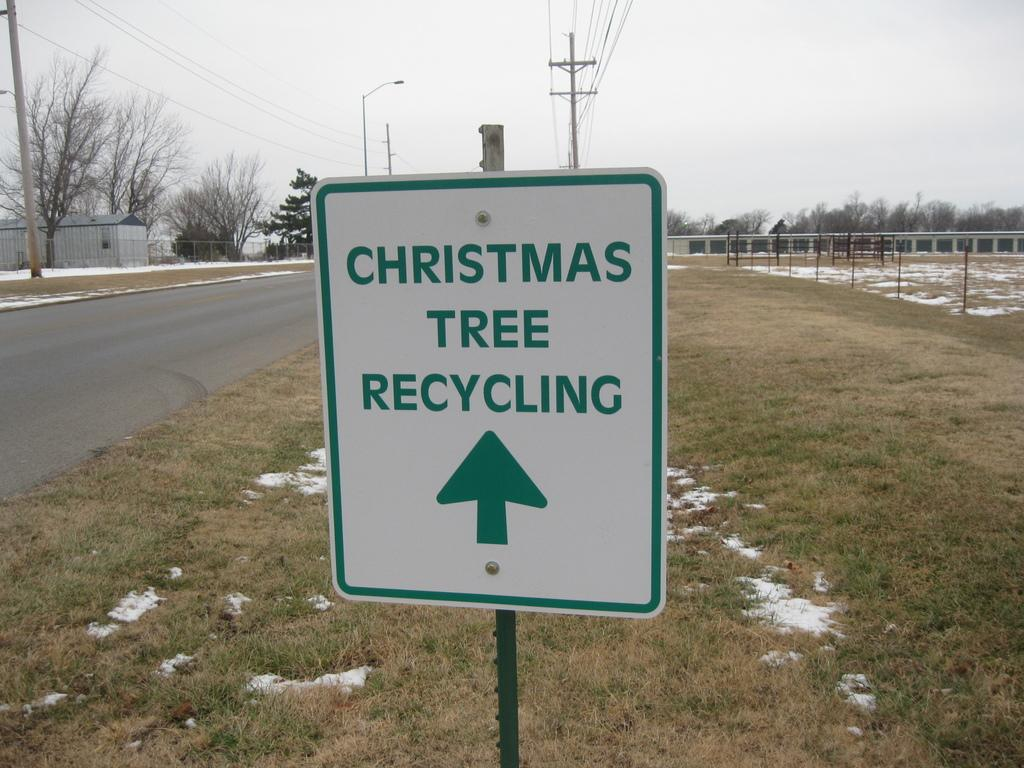<image>
Relay a brief, clear account of the picture shown. a sign that has Christmas Tree Recycling on it 